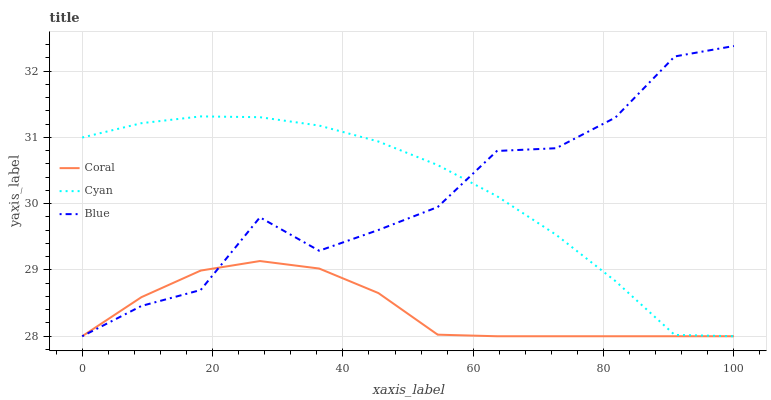Does Coral have the minimum area under the curve?
Answer yes or no. Yes. Does Cyan have the maximum area under the curve?
Answer yes or no. Yes. Does Cyan have the minimum area under the curve?
Answer yes or no. No. Does Coral have the maximum area under the curve?
Answer yes or no. No. Is Cyan the smoothest?
Answer yes or no. Yes. Is Blue the roughest?
Answer yes or no. Yes. Is Coral the smoothest?
Answer yes or no. No. Is Coral the roughest?
Answer yes or no. No. Does Blue have the lowest value?
Answer yes or no. Yes. Does Blue have the highest value?
Answer yes or no. Yes. Does Cyan have the highest value?
Answer yes or no. No. Does Blue intersect Coral?
Answer yes or no. Yes. Is Blue less than Coral?
Answer yes or no. No. Is Blue greater than Coral?
Answer yes or no. No. 